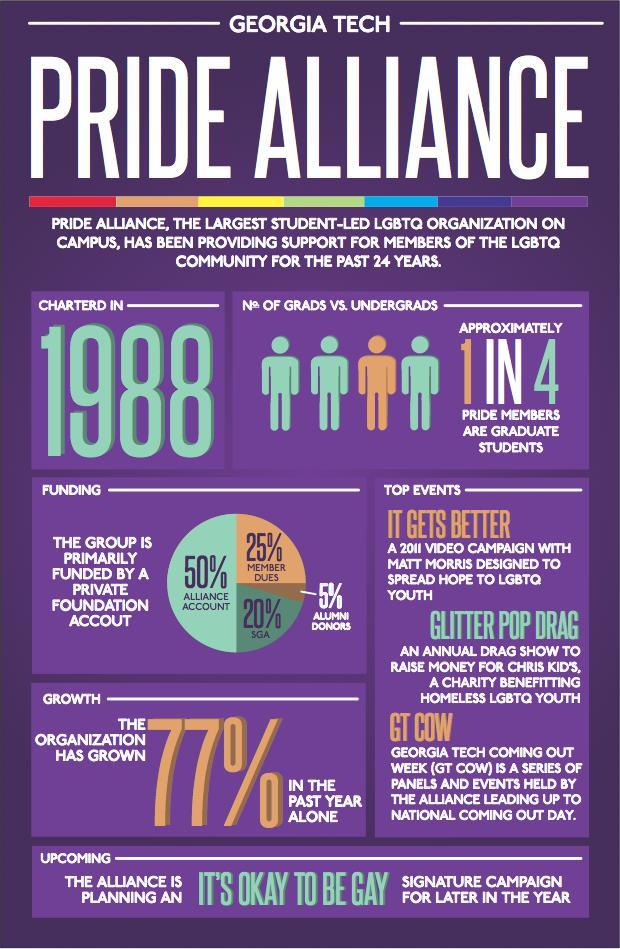How many students of LGBTQ community are Under Graduates?
Answer the question with a short phrase. 3 What percentage of Pride Alliance is funded by SGA? 20% What percentage of Pride Alliance is funded by Member Dues? 25% What percentage of Pride Alliance is funded by Alumni Donors? 5% Who is the highest fund provider of Pride Alliance? Alliance Account 